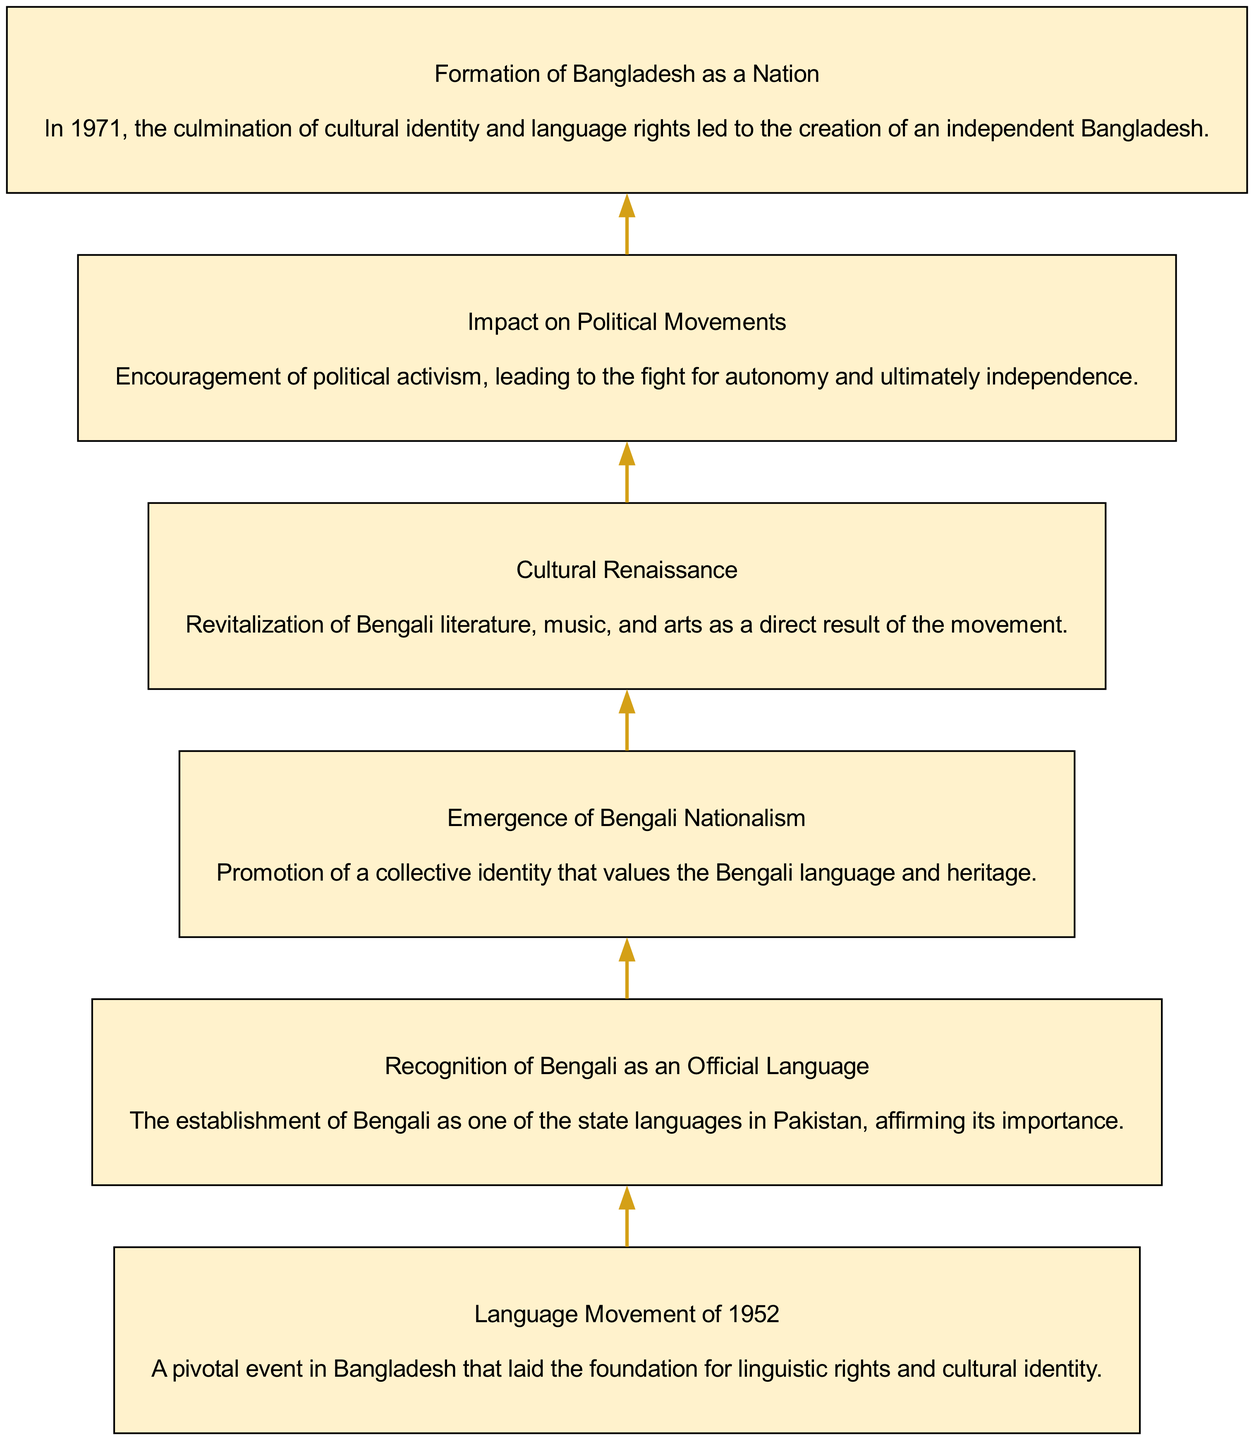What is the first element in the diagram? The first node in the bottom-up flow chart represents the starting point of the impact, which is the "Language Movement of 1952".
Answer: Language Movement of 1952 What is the last element in the diagram? The final node shows the culmination of the events and movements represented, which is "Formation of Bangladesh as a Nation".
Answer: Formation of Bangladesh as a Nation How many nodes are present in the diagram? By counting the individual labeled rectangles in the diagram, we find that there are a total of six nodes representing different impacts of the Language Movement.
Answer: 6 What relationship exists between "Cultural Renaissance" and "Emergence of Bengali Nationalism"? In the diagram, there is a sequential flow indicating that "Cultural Renaissance" occurs as a result of and alongside the collective identity emphasized in "Emergence of Bengali Nationalism".
Answer: Sequential relationship What is the main consequence of the "Language Movement of 1952"? The fundamental outcome illustrated in the diagram is the "Recognition of Bengali as an Official Language", which is a direct impact of the movement.
Answer: Recognition of Bengali as an Official Language How does "Impact on Political Movements" relate to "Formation of Bangladesh as a Nation"? The diagram shows that "Impact on Political Movements" leads to a significant political awakening that ultimately results in the "Formation of Bangladesh as a Nation", indicating a cause-and-effect relationship.
Answer: Cause-and-effect relationship What was a major cultural result stemming from the Language Movement? The node labeled "Cultural Renaissance" reflects the revitalization of Bengali culture, signifying one of the major cultural outcomes of the movement.
Answer: Cultural Renaissance What is the significance of the "Recognition of Bengali as an Official Language"? The recognition signifies the establishment of linguistic rights, marking a critical step toward cultural identity as represented in the diagram.
Answer: Establishment of linguistic rights What is the flow direction of the diagram? The flow direction in the bottom-up chart is from the bottom of the diagram upwards, indicating the progression of impacts starting from the Language Movement to the formation of the nation.
Answer: Bottom to top 